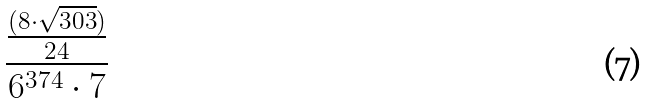Convert formula to latex. <formula><loc_0><loc_0><loc_500><loc_500>\frac { \frac { ( 8 \cdot \sqrt { 3 0 3 } ) } { 2 4 } } { 6 ^ { 3 7 4 } \cdot 7 }</formula> 